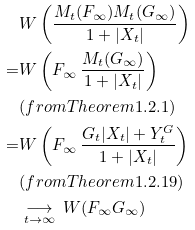Convert formula to latex. <formula><loc_0><loc_0><loc_500><loc_500>& W \left ( \frac { M _ { t } ( F _ { \infty } ) M _ { t } ( G _ { \infty } ) } { 1 + | X _ { t } | } \right ) \\ = & { W } \left ( F _ { \infty } \, \frac { M _ { t } ( G _ { \infty } ) } { 1 + | X _ { t } | } \right ) \\ & ( f r o m T h e o r e m 1 . 2 . 1 ) \\ = & { W } \left ( F _ { \infty } \, \frac { G _ { t } | X _ { t } | + Y _ { t } ^ { G } } { 1 + | X _ { t } | } \right ) \\ & ( f r o m T h e o r e m 1 . 2 . 1 9 ) \\ & \underset { t \rightarrow \infty } { \longrightarrow } \, { W } ( F _ { \infty } G _ { \infty } )</formula> 